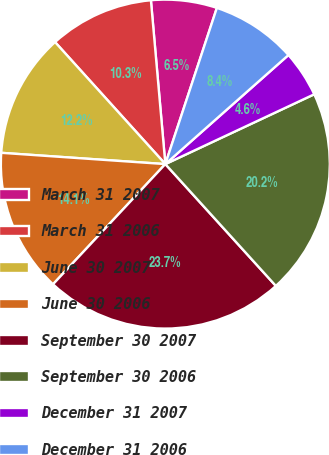<chart> <loc_0><loc_0><loc_500><loc_500><pie_chart><fcel>March 31 2007<fcel>March 31 2006<fcel>June 30 2007<fcel>June 30 2006<fcel>September 30 2007<fcel>September 30 2006<fcel>December 31 2007<fcel>December 31 2006<nl><fcel>6.47%<fcel>10.3%<fcel>12.21%<fcel>14.13%<fcel>23.69%<fcel>20.25%<fcel>4.56%<fcel>8.39%<nl></chart> 